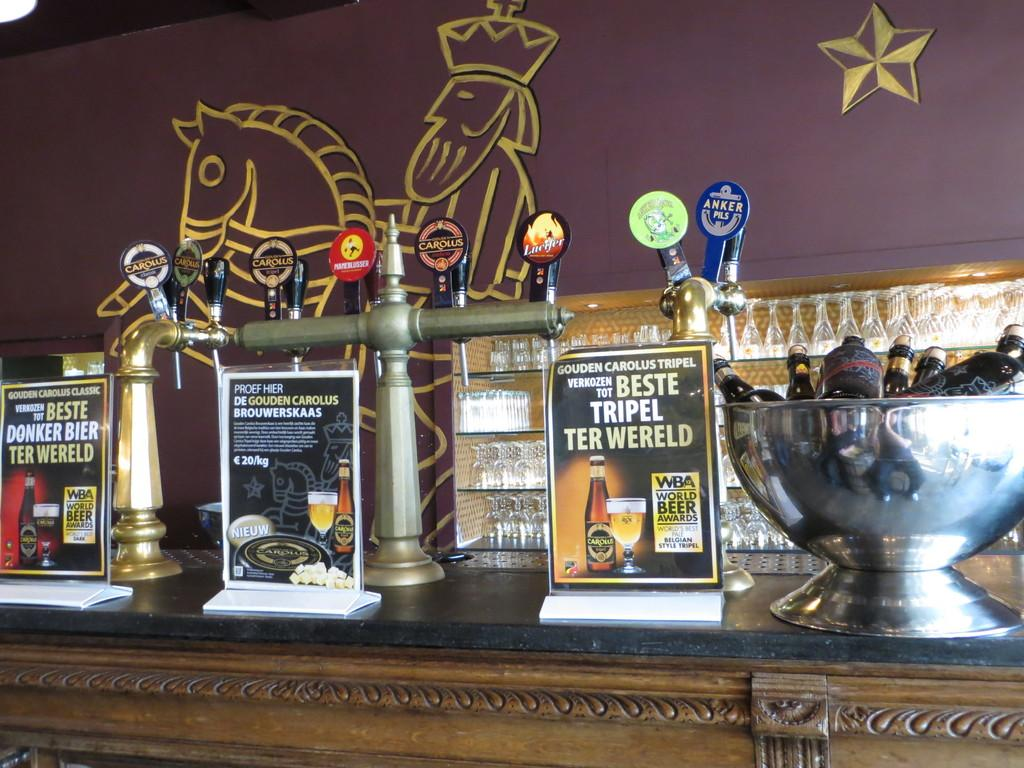What is the main structure in the image? There is a platform in the image. What can be found on the platform? There are objects on the platform. What can be seen in the background of the image? There is a painting on a wall in the background of the image. What type of flame can be seen flickering on the platform in the image? There is no flame present in the image; it only features a platform with objects and a painting on a wall in the background. 